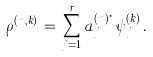Convert formula to latex. <formula><loc_0><loc_0><loc_500><loc_500>\rho ^ { ( n , k ) } \, = \, \sum _ { j = 1 } ^ { r } a _ { j } ^ { ( n ) ^ { * } } \, \psi _ { j } ^ { ( k ) } \, .</formula> 